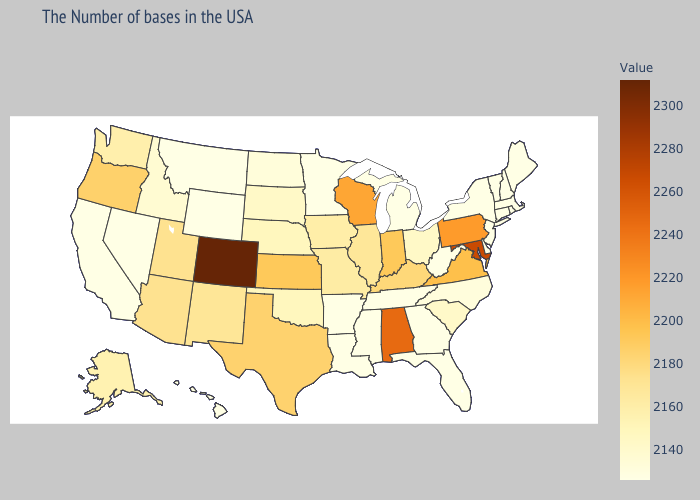Does the map have missing data?
Write a very short answer. No. Does Iowa have a higher value than Kentucky?
Short answer required. No. Does Louisiana have the lowest value in the South?
Give a very brief answer. Yes. Does Arkansas have the highest value in the USA?
Answer briefly. No. Is the legend a continuous bar?
Write a very short answer. Yes. Does Pennsylvania have the highest value in the Northeast?
Concise answer only. Yes. Does the map have missing data?
Keep it brief. No. 